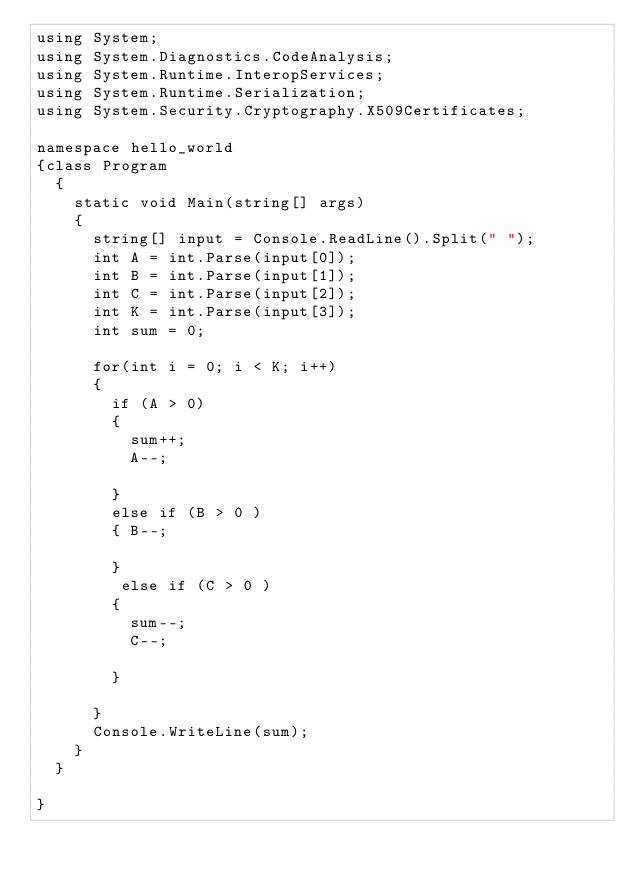<code> <loc_0><loc_0><loc_500><loc_500><_C#_>using System;
using System.Diagnostics.CodeAnalysis;
using System.Runtime.InteropServices;
using System.Runtime.Serialization;
using System.Security.Cryptography.X509Certificates;

namespace hello_world
{class Program
	{
		static void Main(string[] args)
		{
			string[] input = Console.ReadLine().Split(" ");
			int A = int.Parse(input[0]);
			int B = int.Parse(input[1]);
			int C = int.Parse(input[2]);
			int K = int.Parse(input[3]);
			int sum = 0;

			for(int i = 0; i < K; i++)
			{
				if (A > 0)
				{
					sum++;
					A--;
					
				}
				else if (B > 0 )
				{ B--;
					
				}
				 else if (C > 0 )
				{
					sum--;
					C--;
					
				}
				
			}
			Console.WriteLine(sum);
		}
	}

}

	</code> 